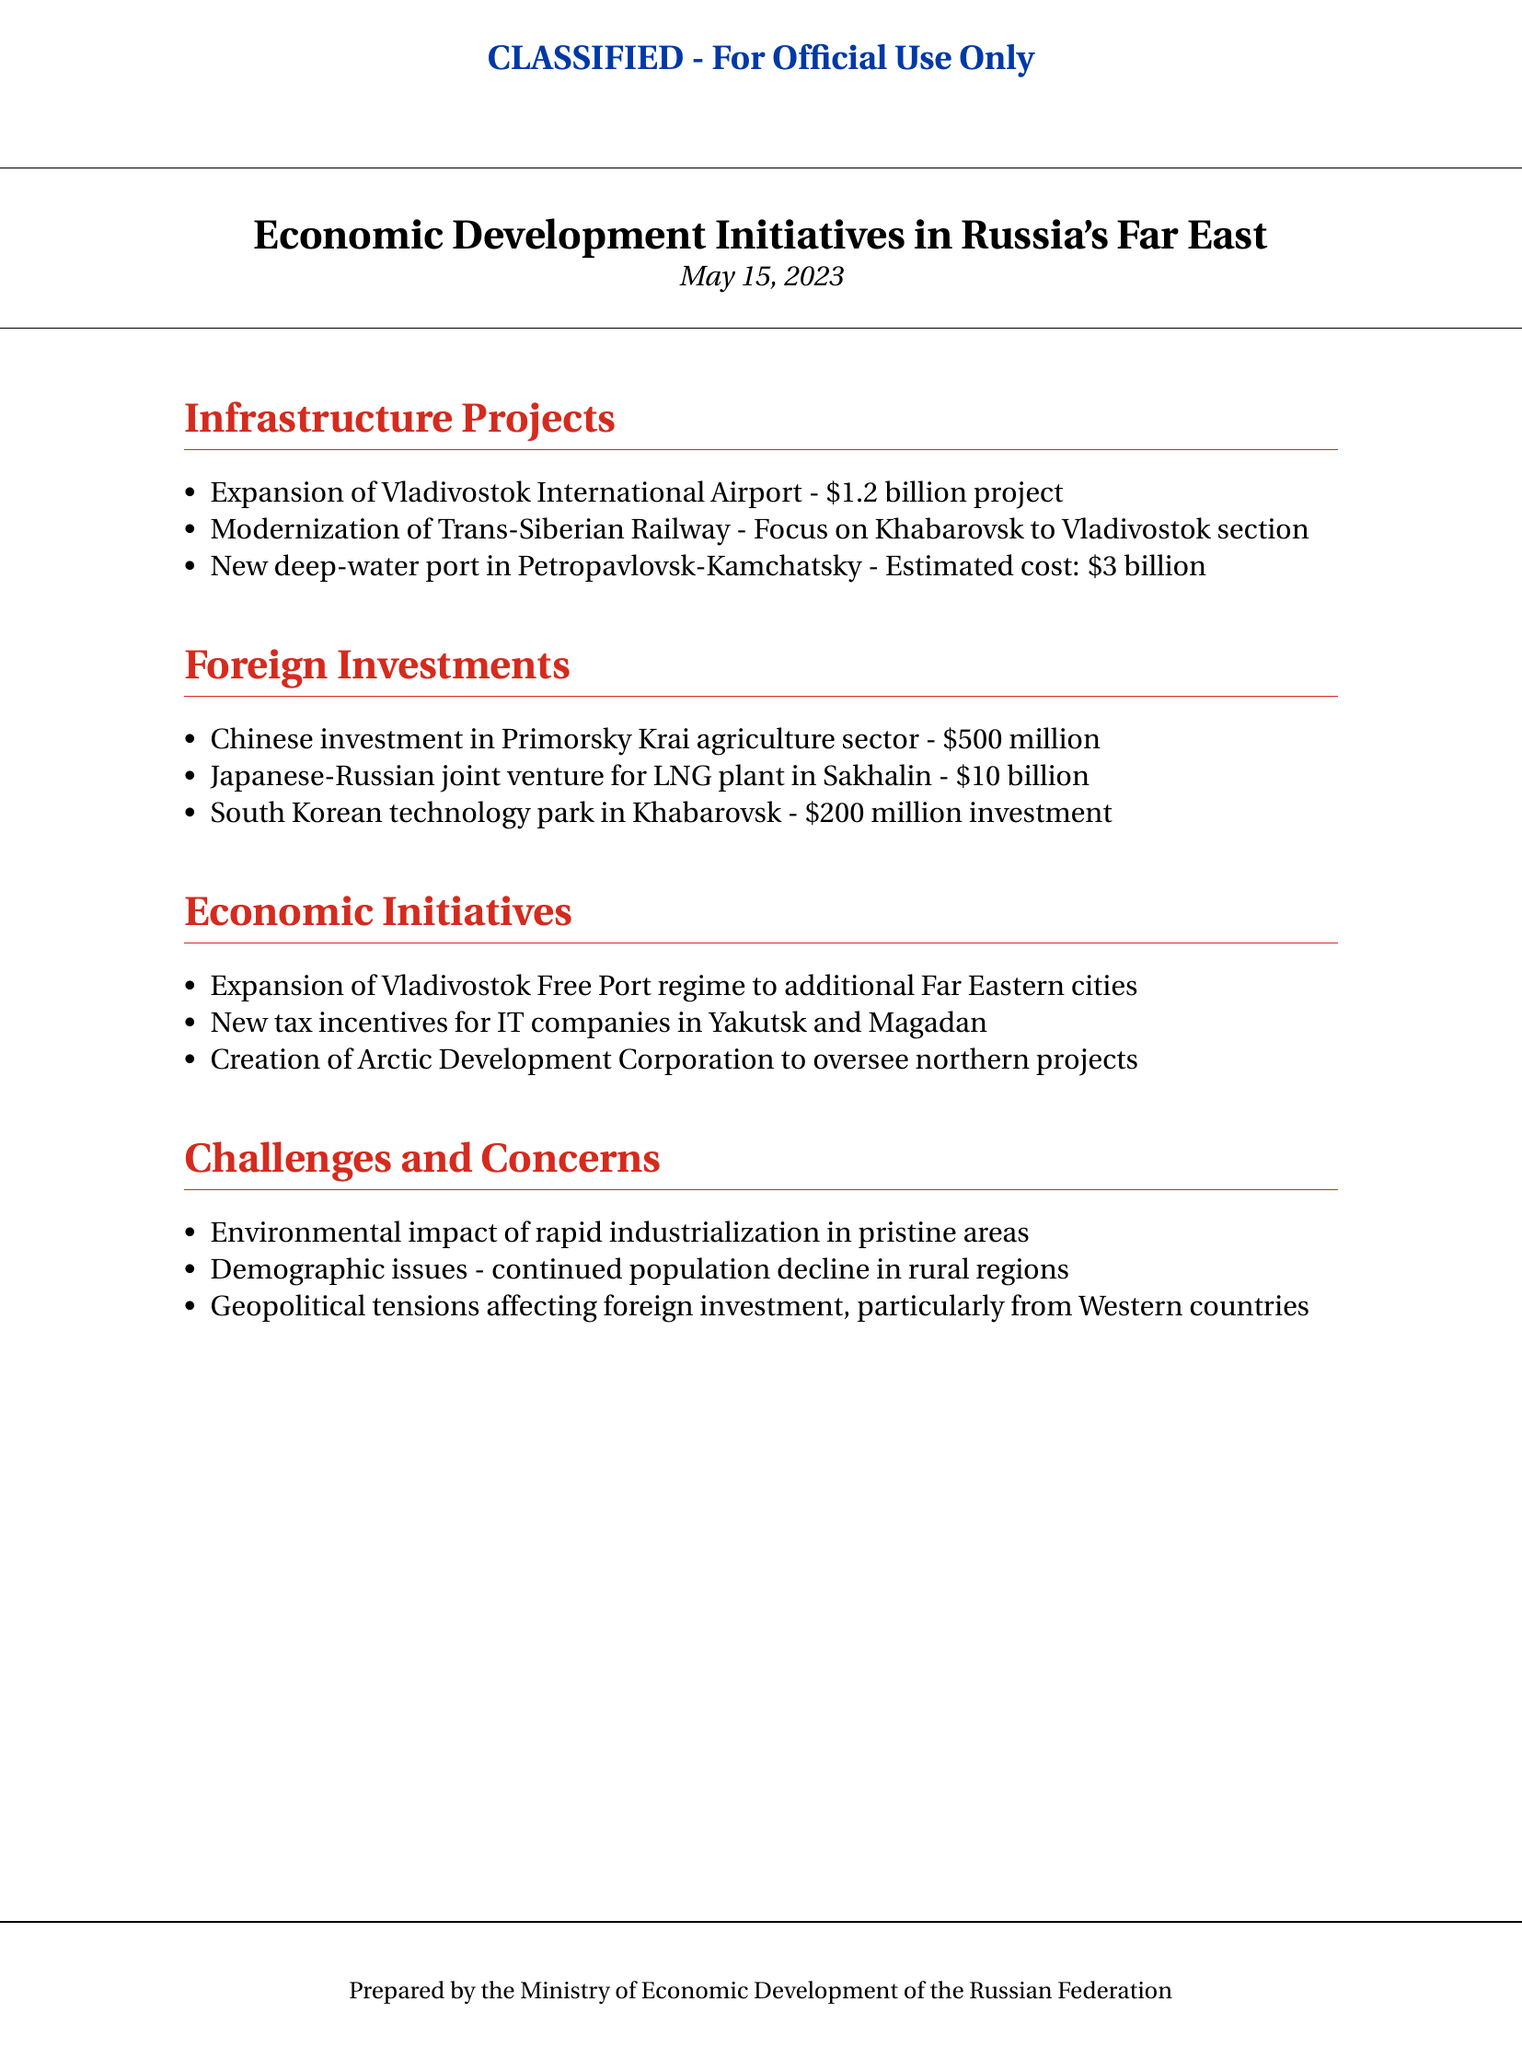what is the estimated cost of the new deep-water port in Petropavlovsk-Kamchatsky? The estimated cost is listed in the document under the infrastructure projects section.
Answer: $3 billion how much is the investment in Primorsky Krai's agriculture sector? The amount is specified in the foreign investments section, highlighting contributions from China.
Answer: $500 million what is the focus of the modernization of the Trans-Siberian Railway? The focus is on a specific section of the railway, as mentioned in the document's infrastructure projects.
Answer: Khabarovsk to Vladivostok section what new regime is being expanded to additional Far Eastern cities? This initiative is identified among the economic initiatives in the document.
Answer: Vladivostok Free Port regime how many billion dollars is the Japanese-Russian joint venture for the LNG plant in Sakhalin? The financial details for this investment are given in the foreign investments section of the document.
Answer: $10 billion what is one of the demographic issues mentioned in the challenges and concerns? A specific demographic issue is indicated under the challenges and concerns section in the document.
Answer: continued population decline what entity is being created to oversee northern projects? This information can be found in the economic initiatives section of the document.
Answer: Arctic Development Corporation what color is used for the section headings in the document? The color specified in the document indicates the visual style of the section headings.
Answer: russiared what type of document is this? The document type is indicated at the top and in the header styling.
Answer: Classified briefing 